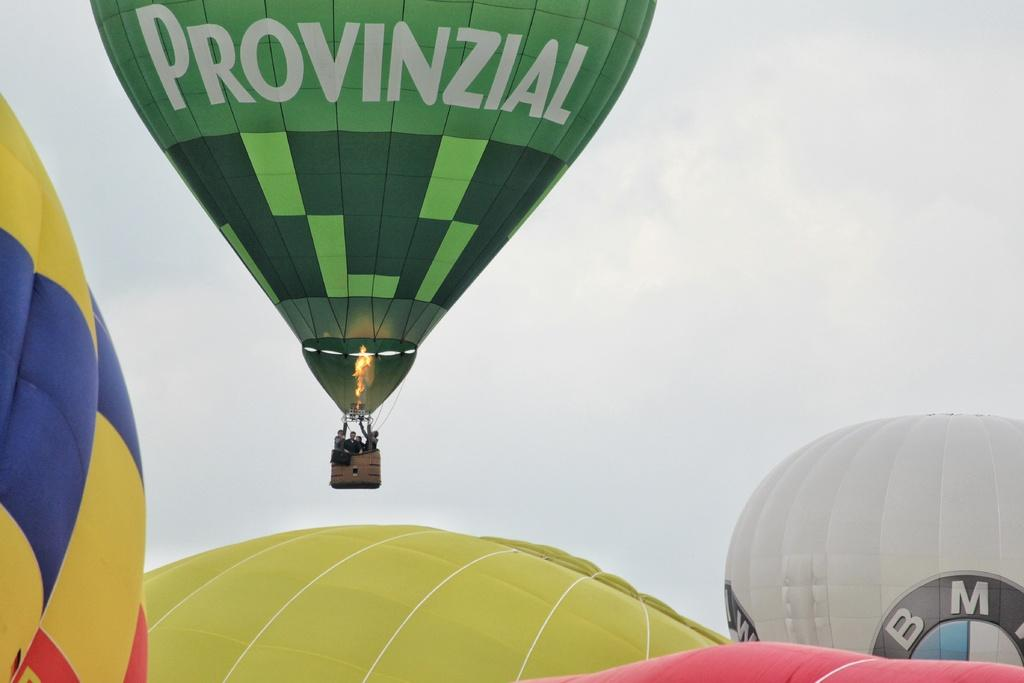What objects are present in the image related to skydiving or parachuting? There are parachutes in the image. Can you describe the people in the image? There are people in the image. What can be seen in the background of the image? The sky is visible in the background of the image. What brand of toothpaste is being advertised in the image? There is no toothpaste or advertisement present in the image. What type of watch is the person wearing in the image? There is no watch visible in the image. 